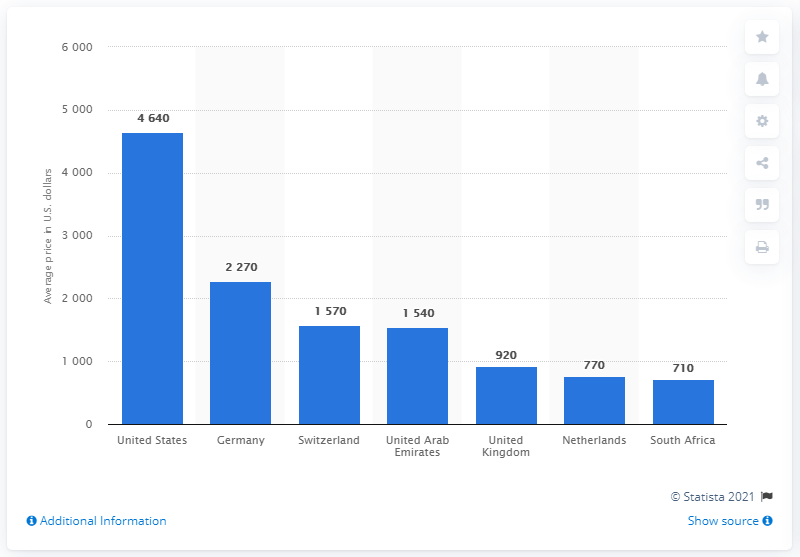Indicate a few pertinent items in this graphic. In 2017, the average price of Enbrel in the Netherlands was approximately 770 euros. 